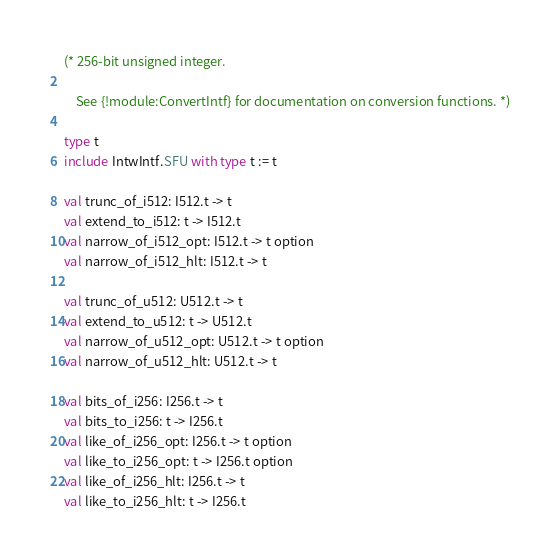<code> <loc_0><loc_0><loc_500><loc_500><_OCaml_>(* 256-bit unsigned integer.

    See {!module:ConvertIntf} for documentation on conversion functions. *)

type t
include IntwIntf.SFU with type t := t

val trunc_of_i512: I512.t -> t
val extend_to_i512: t -> I512.t
val narrow_of_i512_opt: I512.t -> t option
val narrow_of_i512_hlt: I512.t -> t

val trunc_of_u512: U512.t -> t
val extend_to_u512: t -> U512.t
val narrow_of_u512_opt: U512.t -> t option
val narrow_of_u512_hlt: U512.t -> t

val bits_of_i256: I256.t -> t
val bits_to_i256: t -> I256.t
val like_of_i256_opt: I256.t -> t option
val like_to_i256_opt: t -> I256.t option
val like_of_i256_hlt: I256.t -> t
val like_to_i256_hlt: t -> I256.t
</code> 